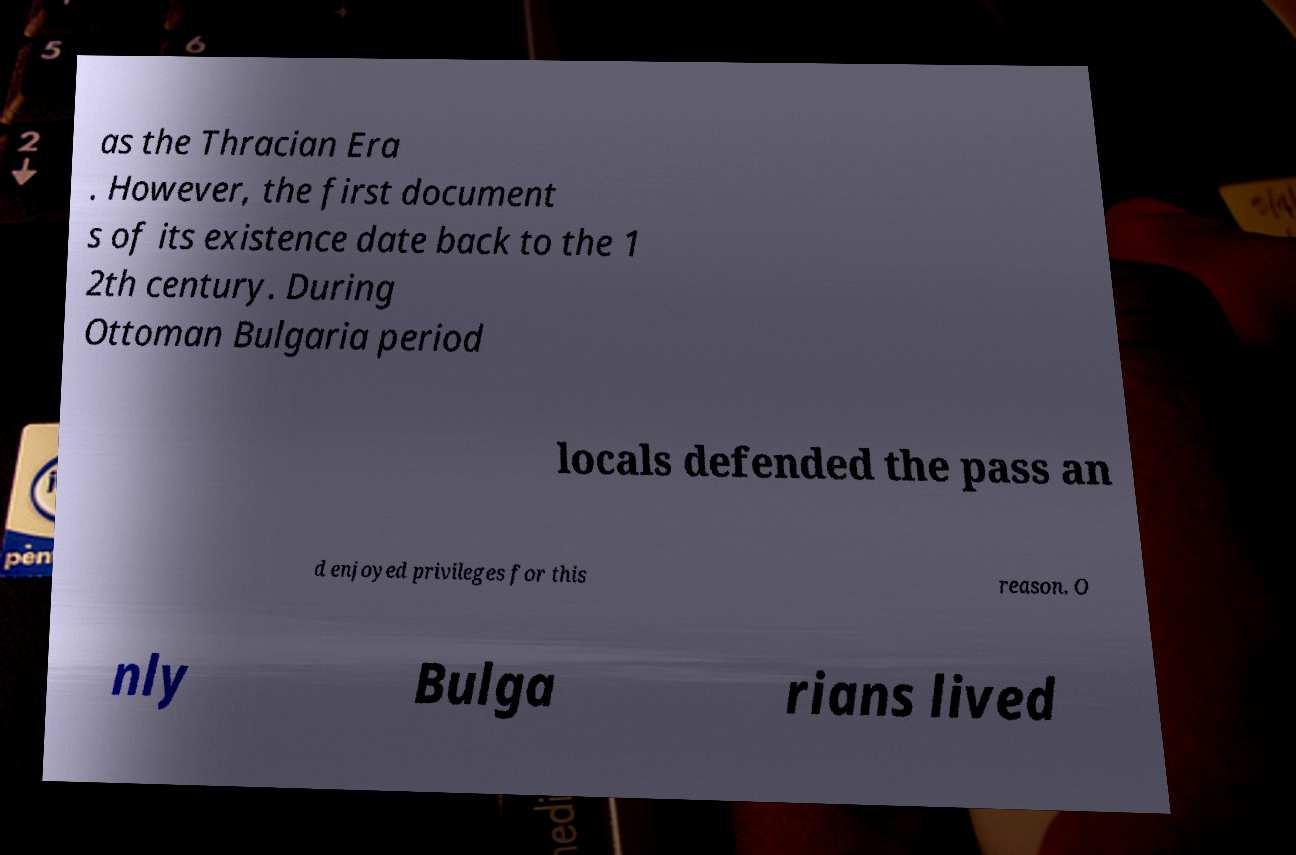What can you tell me about the 'Ottoman Bulgaria period' referred to in the text? The Ottoman Bulgaria period refers to the era from the late 14th century to the early 20th century when Bulgaria was part of the Ottoman Empire. This era is characterized by significant cultural and administrative changes. The text mentions locals defending a pass, which highlights local military engagements and possibly special privileges granted for these services, which was common in the empire to ensure loyalty and local governance. 